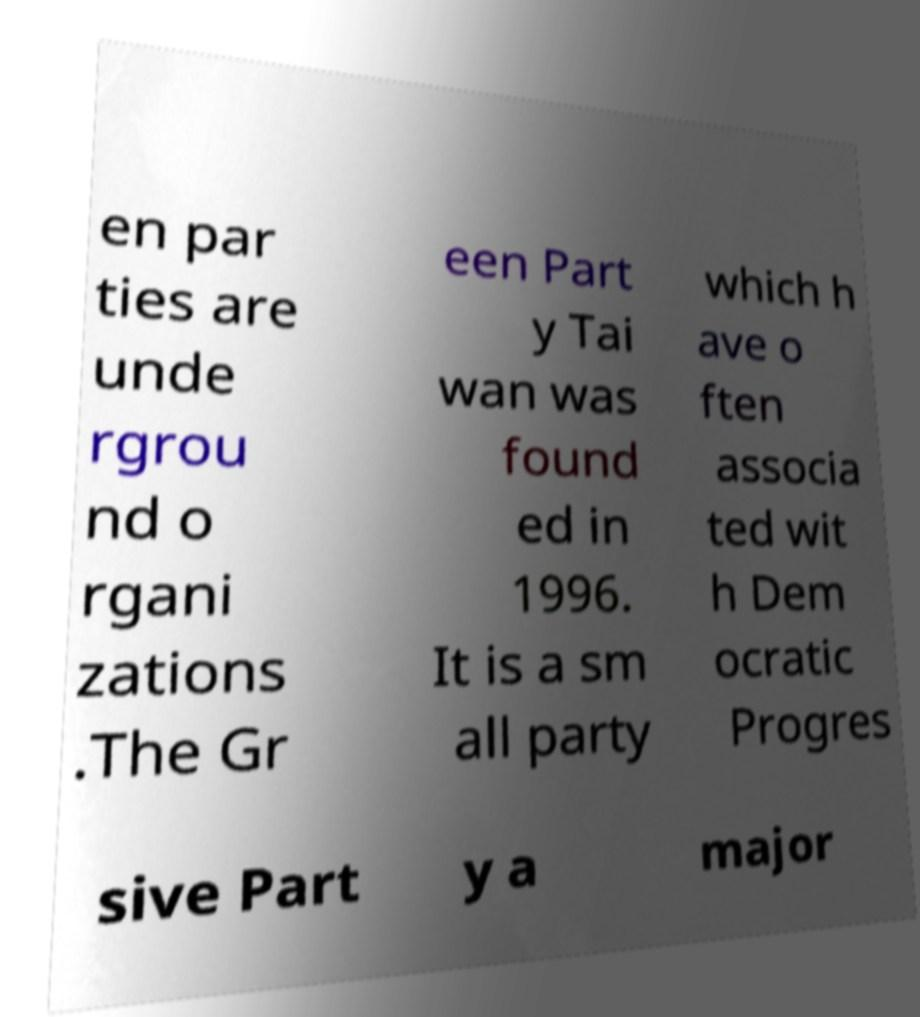Please read and relay the text visible in this image. What does it say? en par ties are unde rgrou nd o rgani zations .The Gr een Part y Tai wan was found ed in 1996. It is a sm all party which h ave o ften associa ted wit h Dem ocratic Progres sive Part y a major 